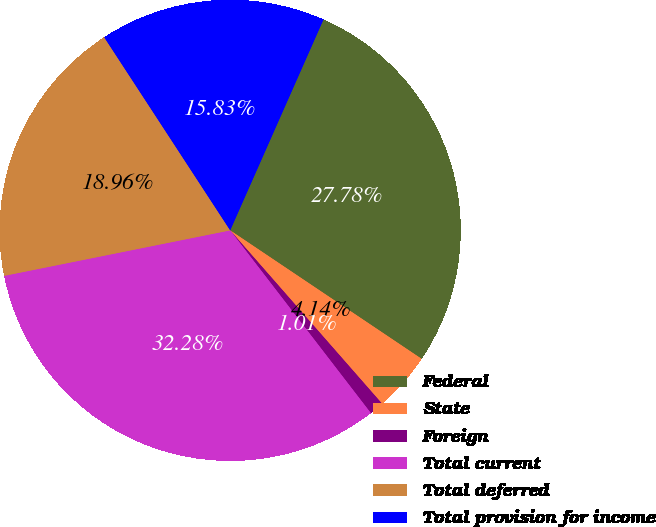Convert chart to OTSL. <chart><loc_0><loc_0><loc_500><loc_500><pie_chart><fcel>Federal<fcel>State<fcel>Foreign<fcel>Total current<fcel>Total deferred<fcel>Total provision for income<nl><fcel>27.78%<fcel>4.14%<fcel>1.01%<fcel>32.28%<fcel>18.96%<fcel>15.83%<nl></chart> 